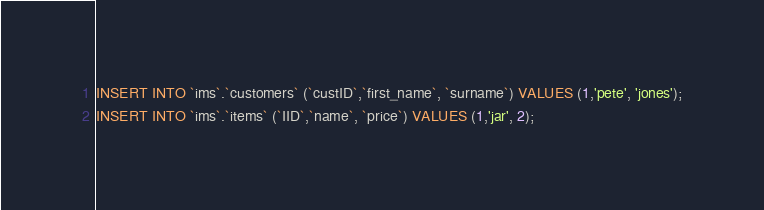<code> <loc_0><loc_0><loc_500><loc_500><_SQL_>INSERT INTO `ims`.`customers` (`custID`,`first_name`, `surname`) VALUES (1,'pete', 'jones');
INSERT INTO `ims`.`items` (`IID`,`name`, `price`) VALUES (1,'jar', 2);
</code> 